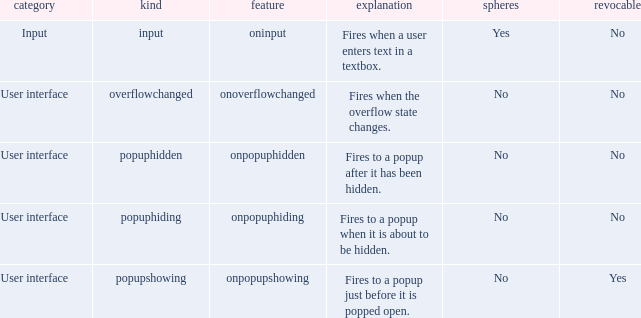What's the attribute with cancelable being yes Onpopupshowing. 